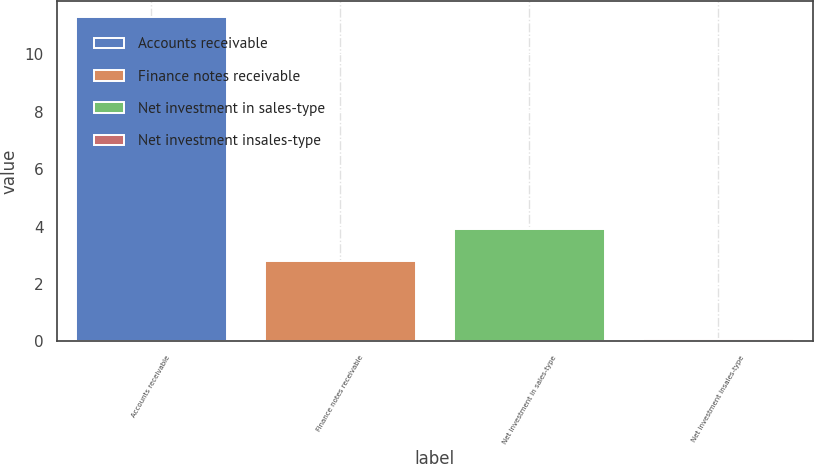Convert chart to OTSL. <chart><loc_0><loc_0><loc_500><loc_500><bar_chart><fcel>Accounts receivable<fcel>Finance notes receivable<fcel>Net investment in sales-type<fcel>Net investment insales-type<nl><fcel>11.3<fcel>2.8<fcel>3.92<fcel>0.1<nl></chart> 